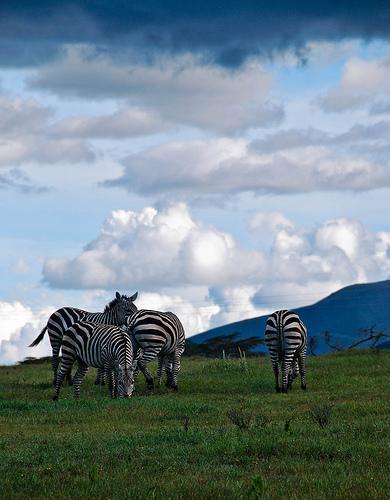How many zebras are in the picture?
Give a very brief answer. 4. 